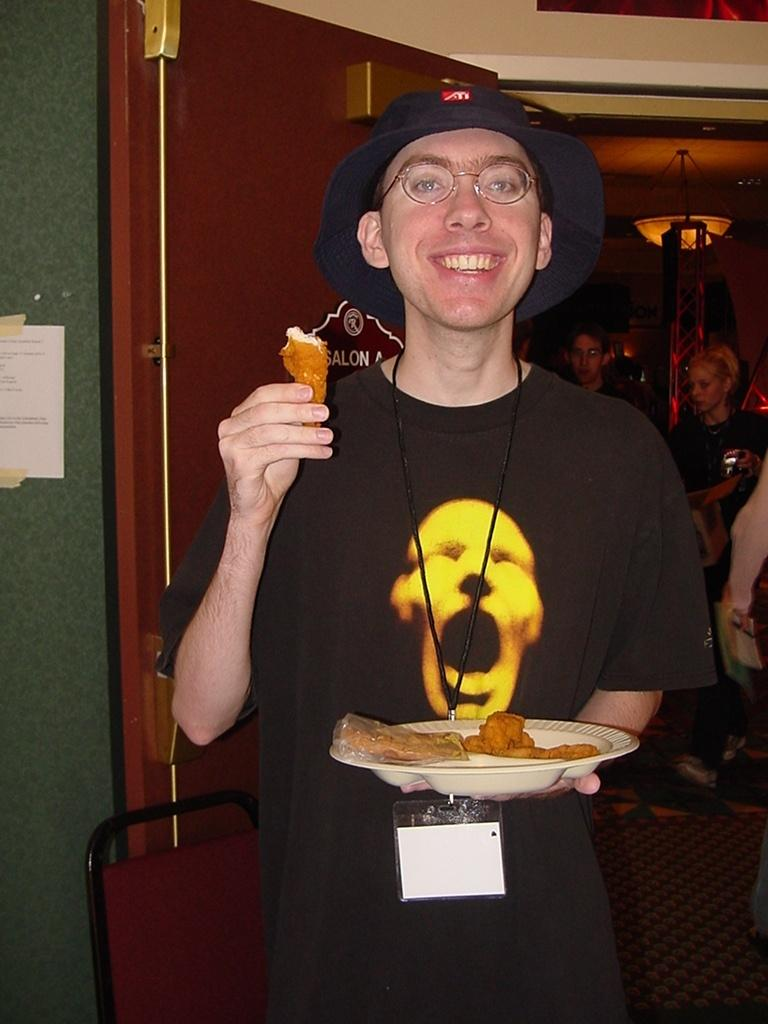What is the person in the middle of the image doing? The person is standing in the middle of the image and holding a plate. What is the person's facial expression? The person is smiling. What is located behind the person? There is a chair visible behind the person. What can be seen in the background of the image? There is a wall and a door in the background, as well as people standing there. What song is the person singing in the image? There is no indication in the image that the person is singing, so it cannot be determined from the picture. 